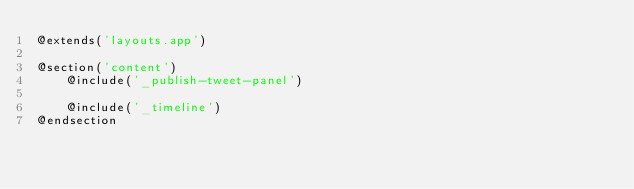<code> <loc_0><loc_0><loc_500><loc_500><_PHP_>@extends('layouts.app')

@section('content')
    @include('_publish-tweet-panel')
                
    @include('_timeline')
@endsection
</code> 